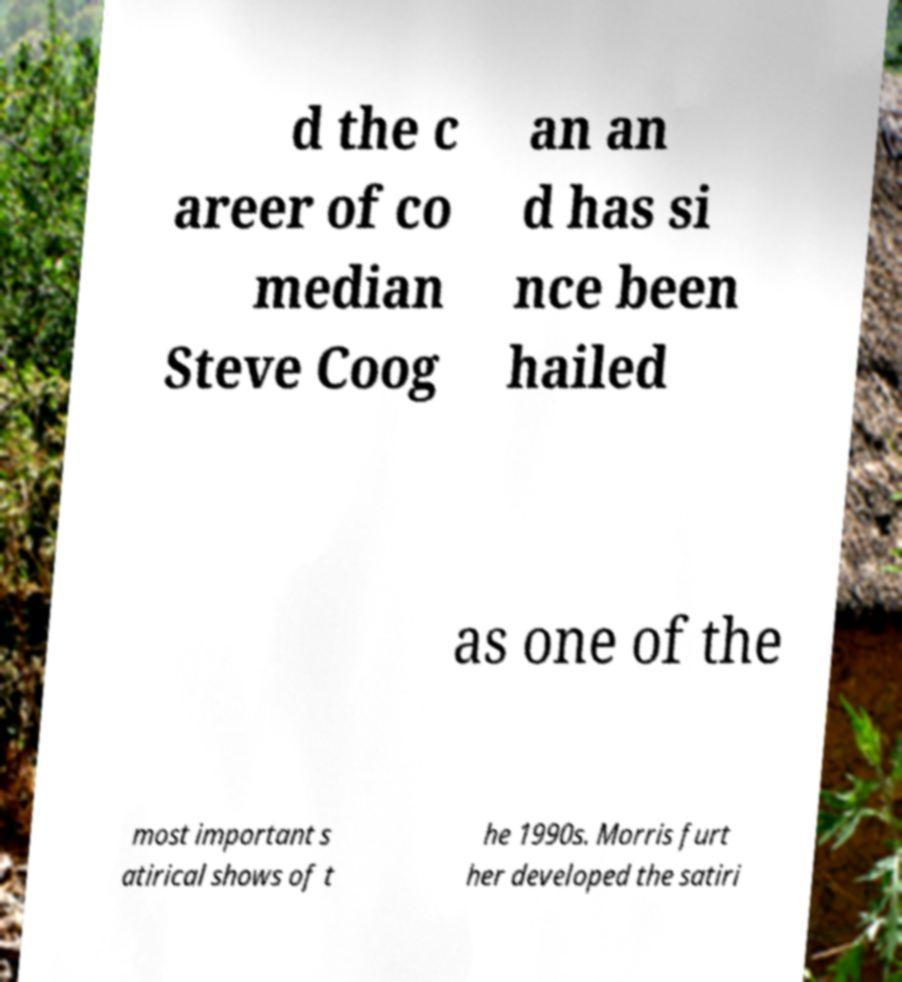Please identify and transcribe the text found in this image. d the c areer of co median Steve Coog an an d has si nce been hailed as one of the most important s atirical shows of t he 1990s. Morris furt her developed the satiri 